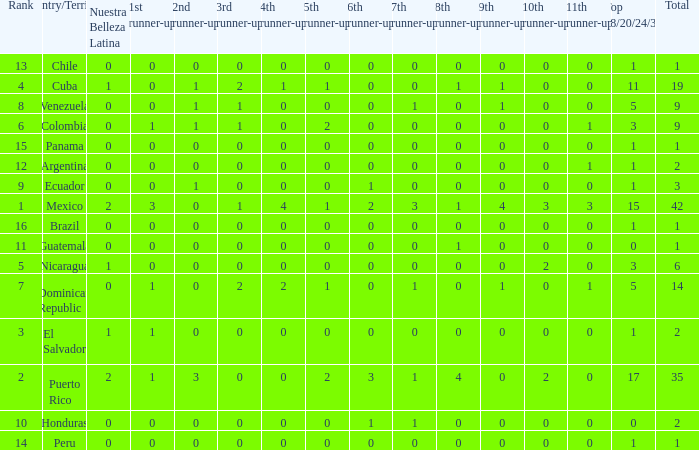What is the 3rd runner-up of the country with more than 0 9th runner-up, an 11th runner-up of 0, and the 1st runner-up greater than 0? None. 